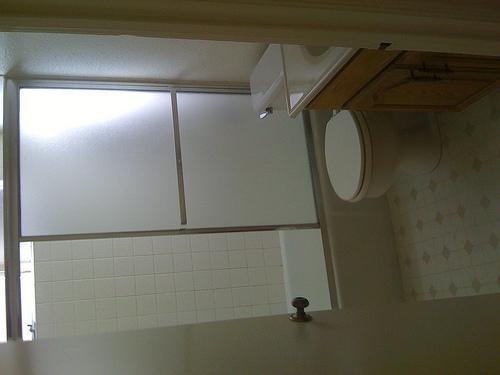Question: when is this?
Choices:
A. High noon.
B. After a storm.
C. Early morning.
D. Daytime.
Answer with the letter. Answer: D Question: why was this photo taken?
Choices:
A. To show a bedroom.
B. To show a kitchen.
C. To show a bathroom.
D. To show a living room.
Answer with the letter. Answer: C Question: what color are the tiles?
Choices:
A. Red.
B. Yellow.
C. Blue.
D. Beige.
Answer with the letter. Answer: D Question: where is this scene?
Choices:
A. Inside a car.
B. Inside an airplane.
C. A car accident.
D. A bathroom.
Answer with the letter. Answer: D Question: where was this photo taken?
Choices:
A. In a bathroom.
B. In the bedroom.
C. In the kitchen.
D. On the patio.
Answer with the letter. Answer: A Question: who captured this photo?
Choices:
A. A photographer.
B. A man.
C. A woman.
D. A stranger.
Answer with the letter. Answer: A 